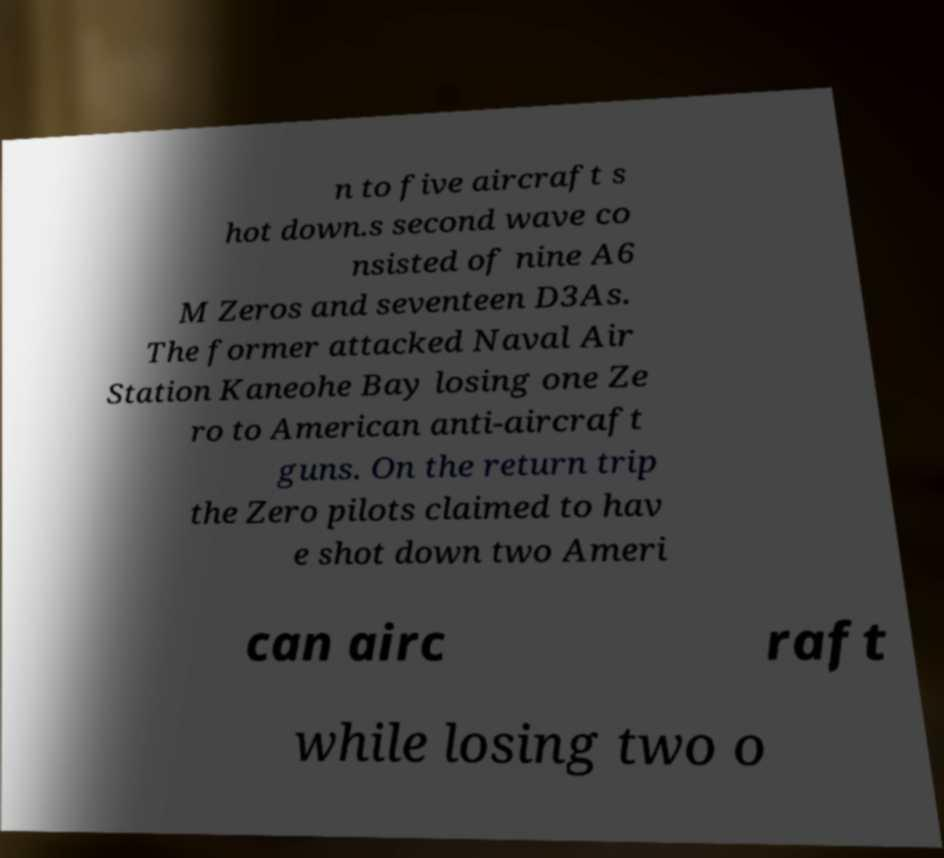Can you accurately transcribe the text from the provided image for me? n to five aircraft s hot down.s second wave co nsisted of nine A6 M Zeros and seventeen D3As. The former attacked Naval Air Station Kaneohe Bay losing one Ze ro to American anti-aircraft guns. On the return trip the Zero pilots claimed to hav e shot down two Ameri can airc raft while losing two o 